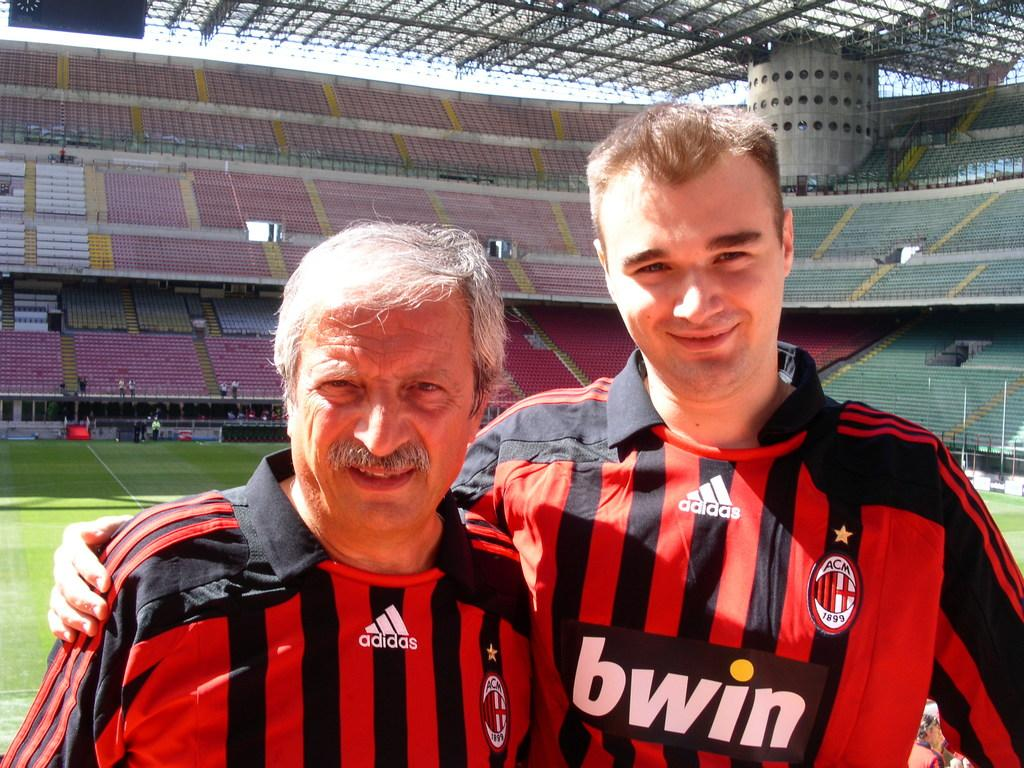<image>
Present a compact description of the photo's key features. Two men in adidas jerseys are in a large stadium. 